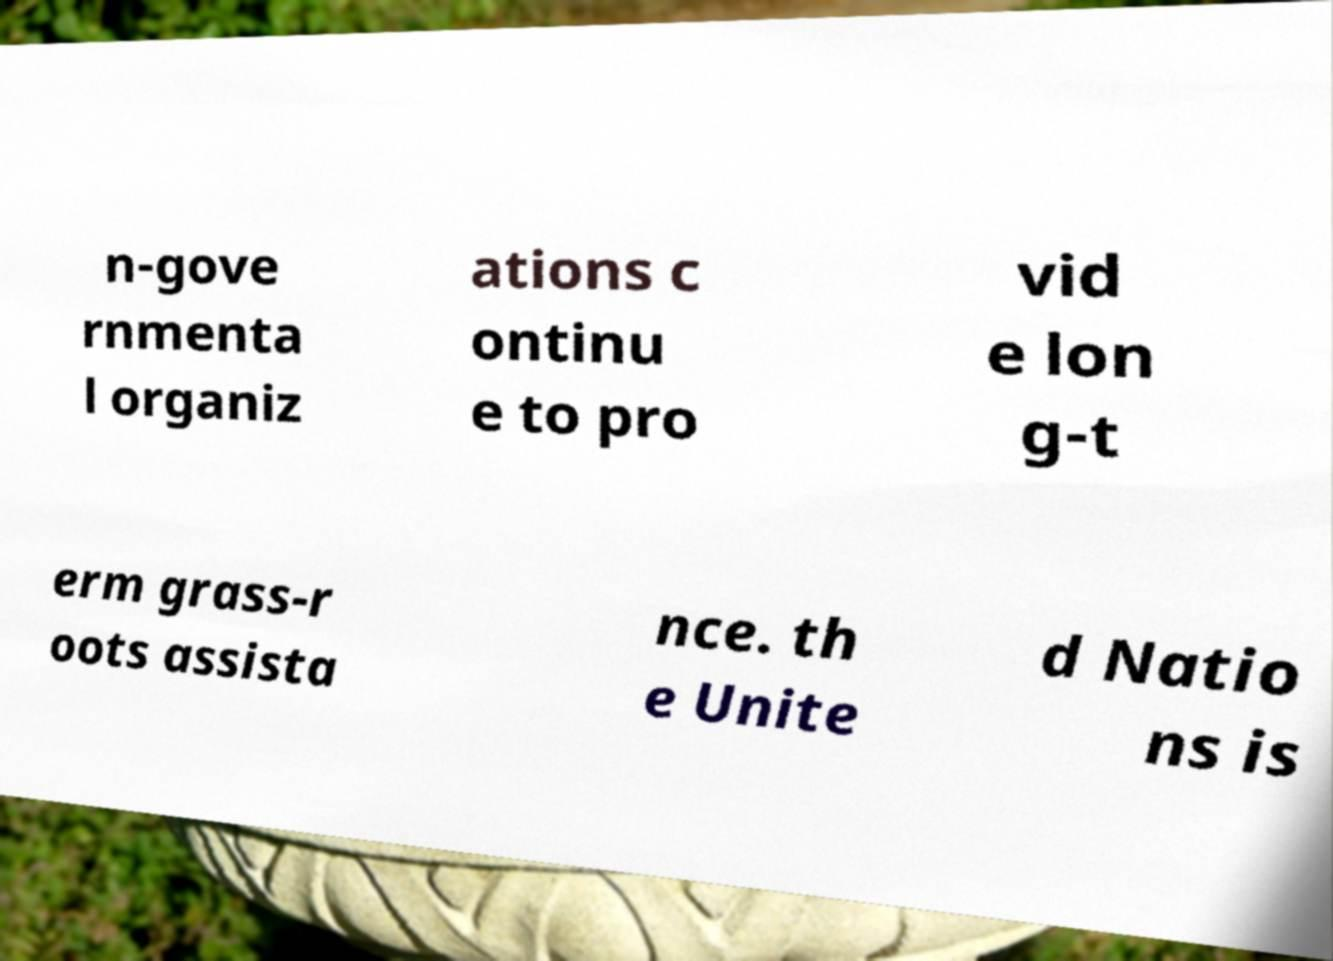Could you extract and type out the text from this image? n-gove rnmenta l organiz ations c ontinu e to pro vid e lon g-t erm grass-r oots assista nce. th e Unite d Natio ns is 